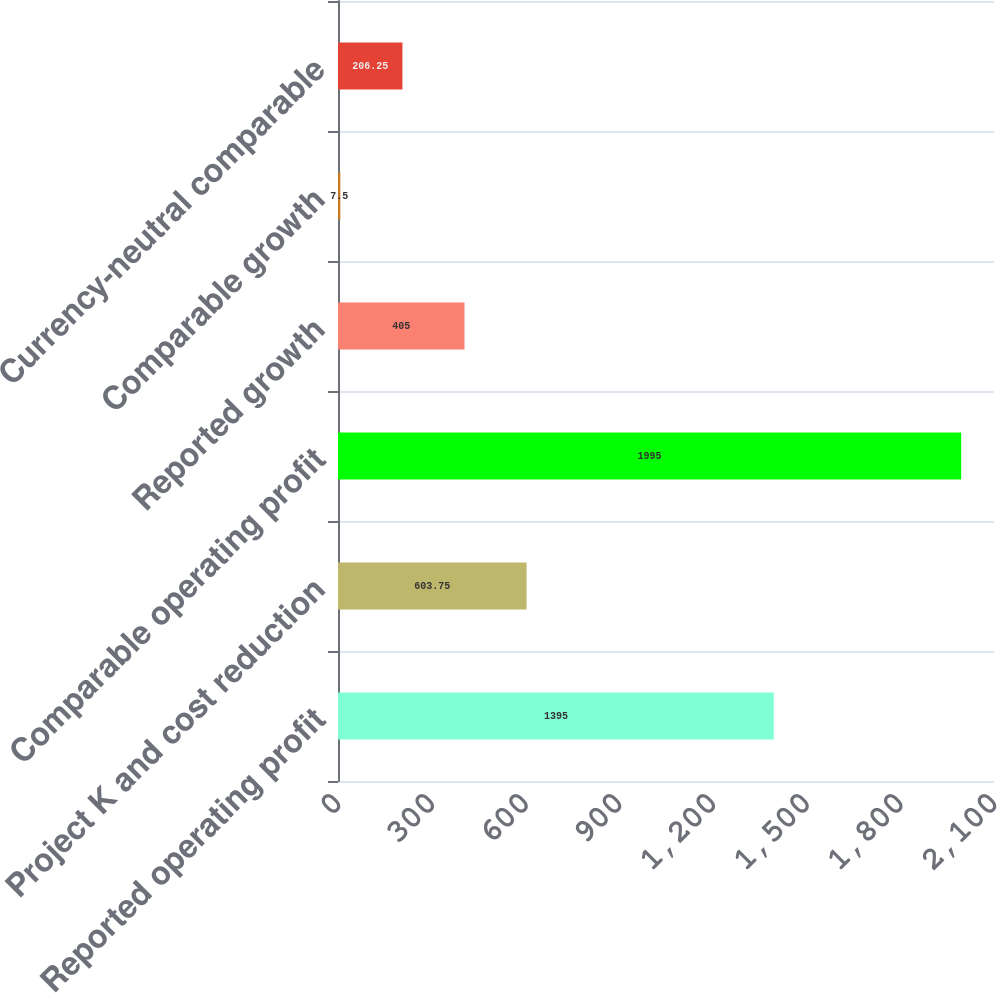<chart> <loc_0><loc_0><loc_500><loc_500><bar_chart><fcel>Reported operating profit<fcel>Project K and cost reduction<fcel>Comparable operating profit<fcel>Reported growth<fcel>Comparable growth<fcel>Currency-neutral comparable<nl><fcel>1395<fcel>603.75<fcel>1995<fcel>405<fcel>7.5<fcel>206.25<nl></chart> 